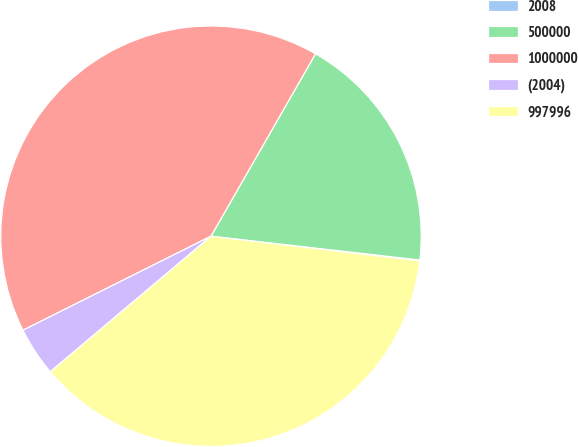Convert chart. <chart><loc_0><loc_0><loc_500><loc_500><pie_chart><fcel>2008<fcel>500000<fcel>1000000<fcel>(2004)<fcel>997996<nl><fcel>0.07%<fcel>18.52%<fcel>40.66%<fcel>3.77%<fcel>36.97%<nl></chart> 